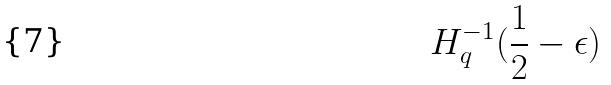<formula> <loc_0><loc_0><loc_500><loc_500>H _ { q } ^ { - 1 } ( \frac { 1 } { 2 } - \epsilon )</formula> 